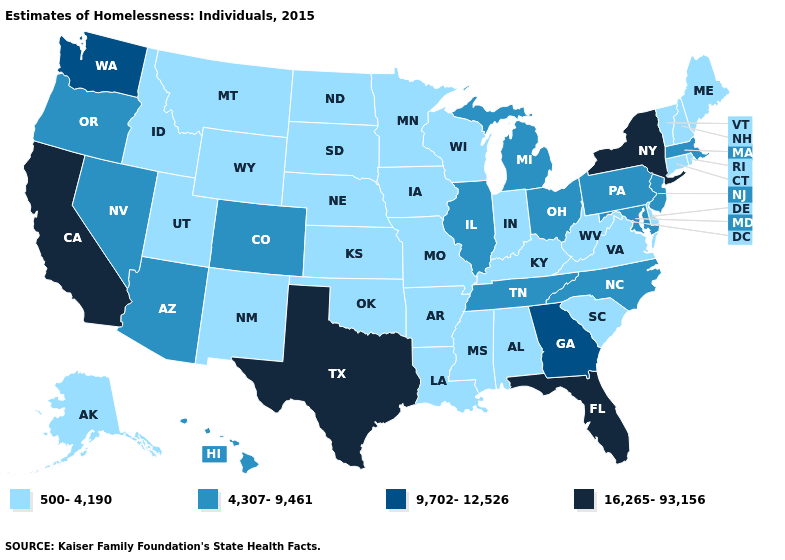What is the value of Maryland?
Short answer required. 4,307-9,461. What is the value of Oklahoma?
Give a very brief answer. 500-4,190. Which states have the lowest value in the USA?
Keep it brief. Alabama, Alaska, Arkansas, Connecticut, Delaware, Idaho, Indiana, Iowa, Kansas, Kentucky, Louisiana, Maine, Minnesota, Mississippi, Missouri, Montana, Nebraska, New Hampshire, New Mexico, North Dakota, Oklahoma, Rhode Island, South Carolina, South Dakota, Utah, Vermont, Virginia, West Virginia, Wisconsin, Wyoming. Is the legend a continuous bar?
Short answer required. No. What is the lowest value in the USA?
Concise answer only. 500-4,190. Name the states that have a value in the range 9,702-12,526?
Short answer required. Georgia, Washington. What is the value of Nevada?
Write a very short answer. 4,307-9,461. Name the states that have a value in the range 4,307-9,461?
Give a very brief answer. Arizona, Colorado, Hawaii, Illinois, Maryland, Massachusetts, Michigan, Nevada, New Jersey, North Carolina, Ohio, Oregon, Pennsylvania, Tennessee. Name the states that have a value in the range 16,265-93,156?
Keep it brief. California, Florida, New York, Texas. Does North Dakota have the highest value in the MidWest?
Concise answer only. No. Does New York have the highest value in the Northeast?
Answer briefly. Yes. What is the value of Ohio?
Be succinct. 4,307-9,461. Name the states that have a value in the range 9,702-12,526?
Quick response, please. Georgia, Washington. Is the legend a continuous bar?
Quick response, please. No. What is the value of Oregon?
Give a very brief answer. 4,307-9,461. 